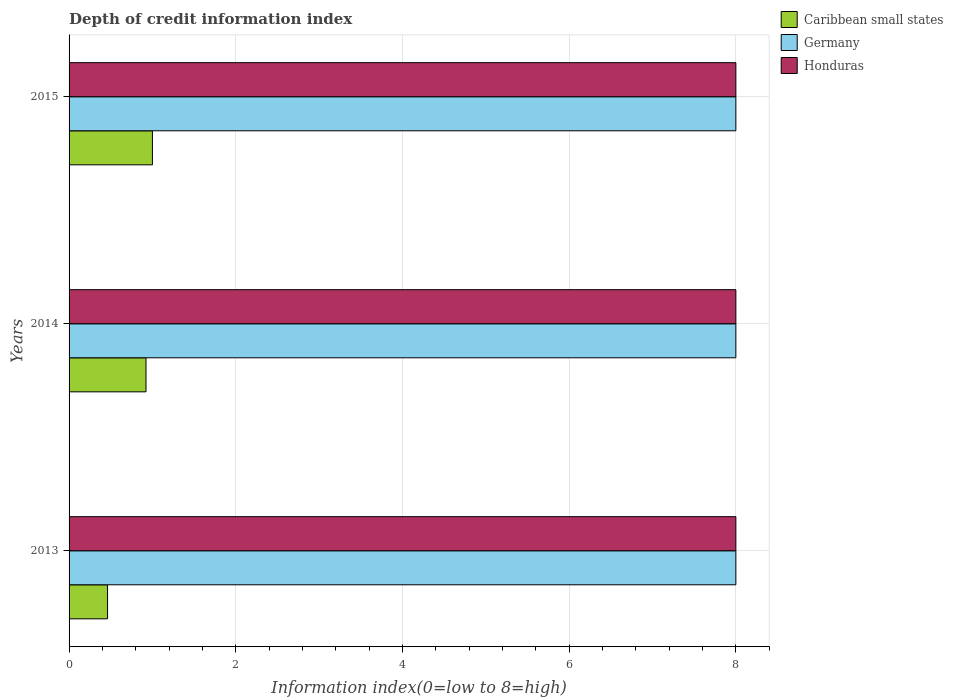How many groups of bars are there?
Offer a very short reply. 3. Are the number of bars on each tick of the Y-axis equal?
Ensure brevity in your answer.  Yes. How many bars are there on the 3rd tick from the top?
Your answer should be very brief. 3. How many bars are there on the 2nd tick from the bottom?
Keep it short and to the point. 3. What is the label of the 3rd group of bars from the top?
Your answer should be compact. 2013. What is the information index in Caribbean small states in 2014?
Your answer should be very brief. 0.92. Across all years, what is the maximum information index in Caribbean small states?
Provide a succinct answer. 1. Across all years, what is the minimum information index in Honduras?
Ensure brevity in your answer.  8. In which year was the information index in Germany minimum?
Make the answer very short. 2013. What is the total information index in Caribbean small states in the graph?
Make the answer very short. 2.38. What is the difference between the information index in Germany in 2014 and the information index in Honduras in 2013?
Offer a very short reply. 0. In the year 2015, what is the difference between the information index in Honduras and information index in Germany?
Provide a short and direct response. 0. What is the ratio of the information index in Caribbean small states in 2013 to that in 2014?
Give a very brief answer. 0.5. Is the information index in Honduras in 2014 less than that in 2015?
Your answer should be compact. No. Is the difference between the information index in Honduras in 2014 and 2015 greater than the difference between the information index in Germany in 2014 and 2015?
Offer a terse response. No. What is the difference between the highest and the second highest information index in Caribbean small states?
Provide a short and direct response. 0.08. What is the difference between the highest and the lowest information index in Caribbean small states?
Keep it short and to the point. 0.54. Is the sum of the information index in Caribbean small states in 2014 and 2015 greater than the maximum information index in Germany across all years?
Keep it short and to the point. No. What does the 1st bar from the top in 2013 represents?
Make the answer very short. Honduras. What does the 1st bar from the bottom in 2015 represents?
Your response must be concise. Caribbean small states. Is it the case that in every year, the sum of the information index in Germany and information index in Caribbean small states is greater than the information index in Honduras?
Offer a terse response. Yes. How many bars are there?
Make the answer very short. 9. How many years are there in the graph?
Give a very brief answer. 3. What is the difference between two consecutive major ticks on the X-axis?
Provide a short and direct response. 2. Does the graph contain any zero values?
Provide a succinct answer. No. Does the graph contain grids?
Make the answer very short. Yes. What is the title of the graph?
Give a very brief answer. Depth of credit information index. Does "High income: nonOECD" appear as one of the legend labels in the graph?
Your response must be concise. No. What is the label or title of the X-axis?
Your response must be concise. Information index(0=low to 8=high). What is the label or title of the Y-axis?
Give a very brief answer. Years. What is the Information index(0=low to 8=high) in Caribbean small states in 2013?
Your response must be concise. 0.46. What is the Information index(0=low to 8=high) of Honduras in 2013?
Your answer should be very brief. 8. What is the Information index(0=low to 8=high) in Caribbean small states in 2014?
Your response must be concise. 0.92. What is the Information index(0=low to 8=high) of Honduras in 2014?
Offer a very short reply. 8. What is the Information index(0=low to 8=high) in Caribbean small states in 2015?
Ensure brevity in your answer.  1. What is the Information index(0=low to 8=high) of Germany in 2015?
Make the answer very short. 8. What is the Information index(0=low to 8=high) of Honduras in 2015?
Provide a succinct answer. 8. Across all years, what is the minimum Information index(0=low to 8=high) of Caribbean small states?
Your response must be concise. 0.46. Across all years, what is the minimum Information index(0=low to 8=high) in Germany?
Provide a succinct answer. 8. What is the total Information index(0=low to 8=high) of Caribbean small states in the graph?
Provide a succinct answer. 2.38. What is the total Information index(0=low to 8=high) of Germany in the graph?
Make the answer very short. 24. What is the difference between the Information index(0=low to 8=high) of Caribbean small states in 2013 and that in 2014?
Your response must be concise. -0.46. What is the difference between the Information index(0=low to 8=high) in Germany in 2013 and that in 2014?
Your response must be concise. 0. What is the difference between the Information index(0=low to 8=high) in Caribbean small states in 2013 and that in 2015?
Ensure brevity in your answer.  -0.54. What is the difference between the Information index(0=low to 8=high) in Germany in 2013 and that in 2015?
Offer a terse response. 0. What is the difference between the Information index(0=low to 8=high) of Honduras in 2013 and that in 2015?
Your answer should be compact. 0. What is the difference between the Information index(0=low to 8=high) of Caribbean small states in 2014 and that in 2015?
Your answer should be very brief. -0.08. What is the difference between the Information index(0=low to 8=high) in Caribbean small states in 2013 and the Information index(0=low to 8=high) in Germany in 2014?
Ensure brevity in your answer.  -7.54. What is the difference between the Information index(0=low to 8=high) in Caribbean small states in 2013 and the Information index(0=low to 8=high) in Honduras in 2014?
Your answer should be compact. -7.54. What is the difference between the Information index(0=low to 8=high) of Germany in 2013 and the Information index(0=low to 8=high) of Honduras in 2014?
Offer a very short reply. 0. What is the difference between the Information index(0=low to 8=high) in Caribbean small states in 2013 and the Information index(0=low to 8=high) in Germany in 2015?
Your answer should be very brief. -7.54. What is the difference between the Information index(0=low to 8=high) in Caribbean small states in 2013 and the Information index(0=low to 8=high) in Honduras in 2015?
Keep it short and to the point. -7.54. What is the difference between the Information index(0=low to 8=high) of Germany in 2013 and the Information index(0=low to 8=high) of Honduras in 2015?
Make the answer very short. 0. What is the difference between the Information index(0=low to 8=high) in Caribbean small states in 2014 and the Information index(0=low to 8=high) in Germany in 2015?
Make the answer very short. -7.08. What is the difference between the Information index(0=low to 8=high) in Caribbean small states in 2014 and the Information index(0=low to 8=high) in Honduras in 2015?
Your answer should be very brief. -7.08. What is the difference between the Information index(0=low to 8=high) in Germany in 2014 and the Information index(0=low to 8=high) in Honduras in 2015?
Offer a terse response. 0. What is the average Information index(0=low to 8=high) in Caribbean small states per year?
Offer a very short reply. 0.79. What is the average Information index(0=low to 8=high) of Germany per year?
Your response must be concise. 8. In the year 2013, what is the difference between the Information index(0=low to 8=high) in Caribbean small states and Information index(0=low to 8=high) in Germany?
Give a very brief answer. -7.54. In the year 2013, what is the difference between the Information index(0=low to 8=high) in Caribbean small states and Information index(0=low to 8=high) in Honduras?
Your answer should be very brief. -7.54. In the year 2014, what is the difference between the Information index(0=low to 8=high) of Caribbean small states and Information index(0=low to 8=high) of Germany?
Provide a succinct answer. -7.08. In the year 2014, what is the difference between the Information index(0=low to 8=high) in Caribbean small states and Information index(0=low to 8=high) in Honduras?
Your answer should be compact. -7.08. In the year 2014, what is the difference between the Information index(0=low to 8=high) of Germany and Information index(0=low to 8=high) of Honduras?
Offer a terse response. 0. In the year 2015, what is the difference between the Information index(0=low to 8=high) of Caribbean small states and Information index(0=low to 8=high) of Honduras?
Your answer should be very brief. -7. In the year 2015, what is the difference between the Information index(0=low to 8=high) in Germany and Information index(0=low to 8=high) in Honduras?
Ensure brevity in your answer.  0. What is the ratio of the Information index(0=low to 8=high) of Honduras in 2013 to that in 2014?
Your answer should be very brief. 1. What is the ratio of the Information index(0=low to 8=high) in Caribbean small states in 2013 to that in 2015?
Make the answer very short. 0.46. What is the ratio of the Information index(0=low to 8=high) in Germany in 2013 to that in 2015?
Give a very brief answer. 1. What is the ratio of the Information index(0=low to 8=high) in Honduras in 2013 to that in 2015?
Your answer should be very brief. 1. What is the ratio of the Information index(0=low to 8=high) of Caribbean small states in 2014 to that in 2015?
Provide a succinct answer. 0.92. What is the ratio of the Information index(0=low to 8=high) of Germany in 2014 to that in 2015?
Offer a very short reply. 1. What is the difference between the highest and the second highest Information index(0=low to 8=high) in Caribbean small states?
Ensure brevity in your answer.  0.08. What is the difference between the highest and the lowest Information index(0=low to 8=high) of Caribbean small states?
Ensure brevity in your answer.  0.54. What is the difference between the highest and the lowest Information index(0=low to 8=high) in Germany?
Provide a short and direct response. 0. What is the difference between the highest and the lowest Information index(0=low to 8=high) of Honduras?
Provide a succinct answer. 0. 